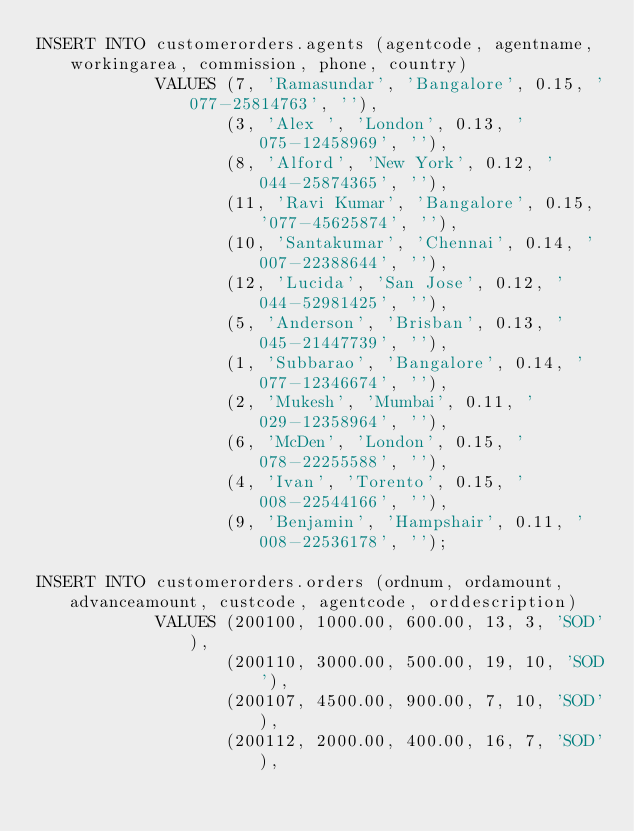<code> <loc_0><loc_0><loc_500><loc_500><_SQL_>INSERT INTO customerorders.agents (agentcode, agentname, workingarea, commission, phone, country)
            VALUES (7, 'Ramasundar', 'Bangalore', 0.15, '077-25814763', ''),
                   (3, 'Alex ', 'London', 0.13, '075-12458969', ''),
                   (8, 'Alford', 'New York', 0.12, '044-25874365', ''),
                   (11, 'Ravi Kumar', 'Bangalore', 0.15, '077-45625874', ''),
                   (10, 'Santakumar', 'Chennai', 0.14, '007-22388644', ''),
                   (12, 'Lucida', 'San Jose', 0.12, '044-52981425', ''),
                   (5, 'Anderson', 'Brisban', 0.13, '045-21447739', ''),
                   (1, 'Subbarao', 'Bangalore', 0.14, '077-12346674', ''),
                   (2, 'Mukesh', 'Mumbai', 0.11, '029-12358964', ''),
                   (6, 'McDen', 'London', 0.15, '078-22255588', ''),
                   (4, 'Ivan', 'Torento', 0.15, '008-22544166', ''),
                   (9, 'Benjamin', 'Hampshair', 0.11, '008-22536178', '');
                   
INSERT INTO customerorders.orders (ordnum, ordamount, advanceamount, custcode, agentcode, orddescription)
            VALUES (200100, 1000.00, 600.00, 13, 3, 'SOD'),
                   (200110, 3000.00, 500.00, 19, 10, 'SOD'),
                   (200107, 4500.00, 900.00, 7, 10, 'SOD'),
                   (200112, 2000.00, 400.00, 16, 7, 'SOD'), </code> 